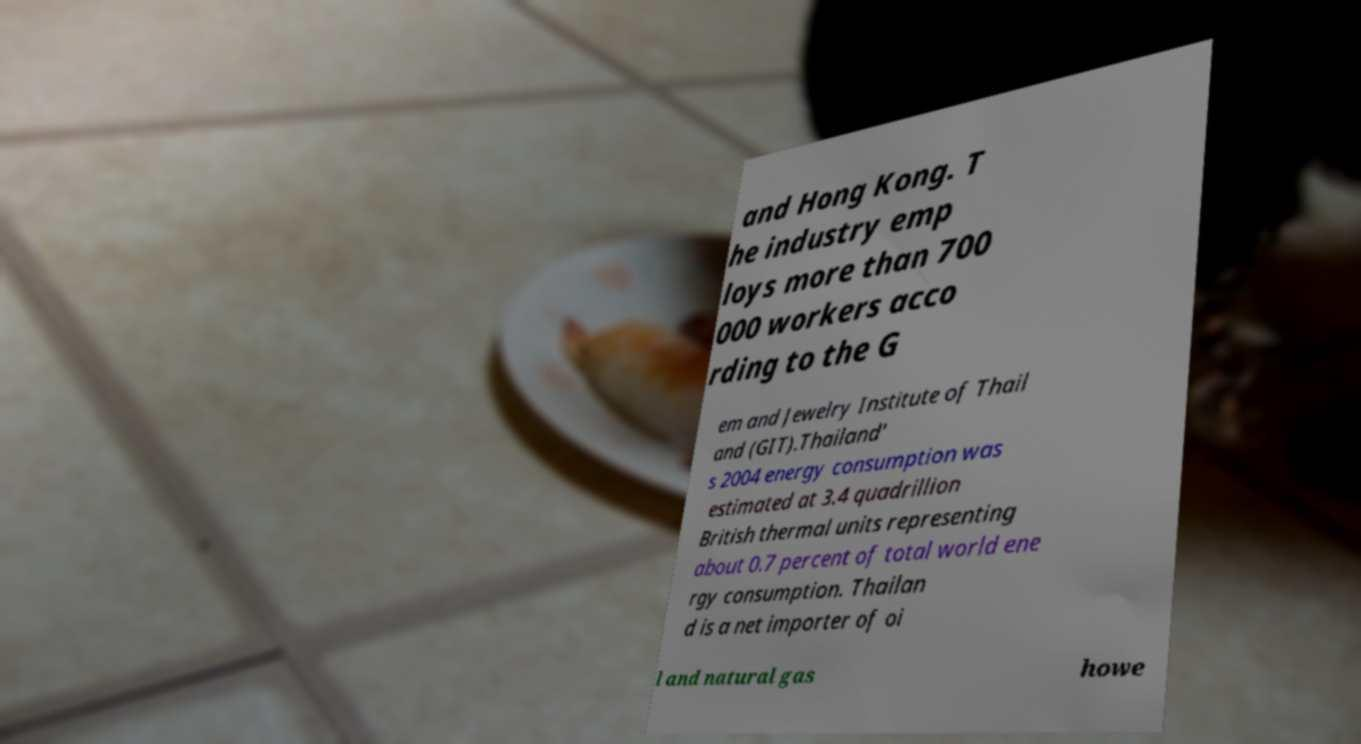Please read and relay the text visible in this image. What does it say? and Hong Kong. T he industry emp loys more than 700 000 workers acco rding to the G em and Jewelry Institute of Thail and (GIT).Thailand' s 2004 energy consumption was estimated at 3.4 quadrillion British thermal units representing about 0.7 percent of total world ene rgy consumption. Thailan d is a net importer of oi l and natural gas howe 